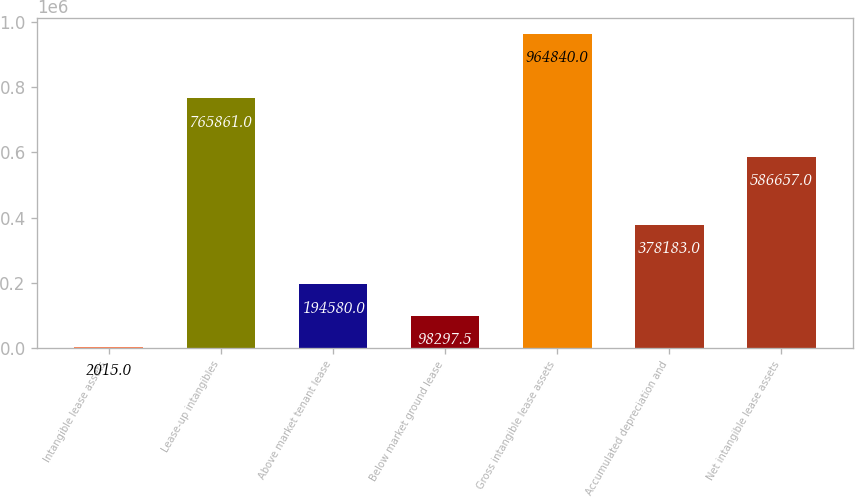<chart> <loc_0><loc_0><loc_500><loc_500><bar_chart><fcel>Intangible lease assets<fcel>Lease-up intangibles<fcel>Above market tenant lease<fcel>Below market ground lease<fcel>Gross intangible lease assets<fcel>Accumulated depreciation and<fcel>Net intangible lease assets<nl><fcel>2015<fcel>765861<fcel>194580<fcel>98297.5<fcel>964840<fcel>378183<fcel>586657<nl></chart> 